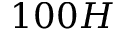<formula> <loc_0><loc_0><loc_500><loc_500>1 0 0 H</formula> 